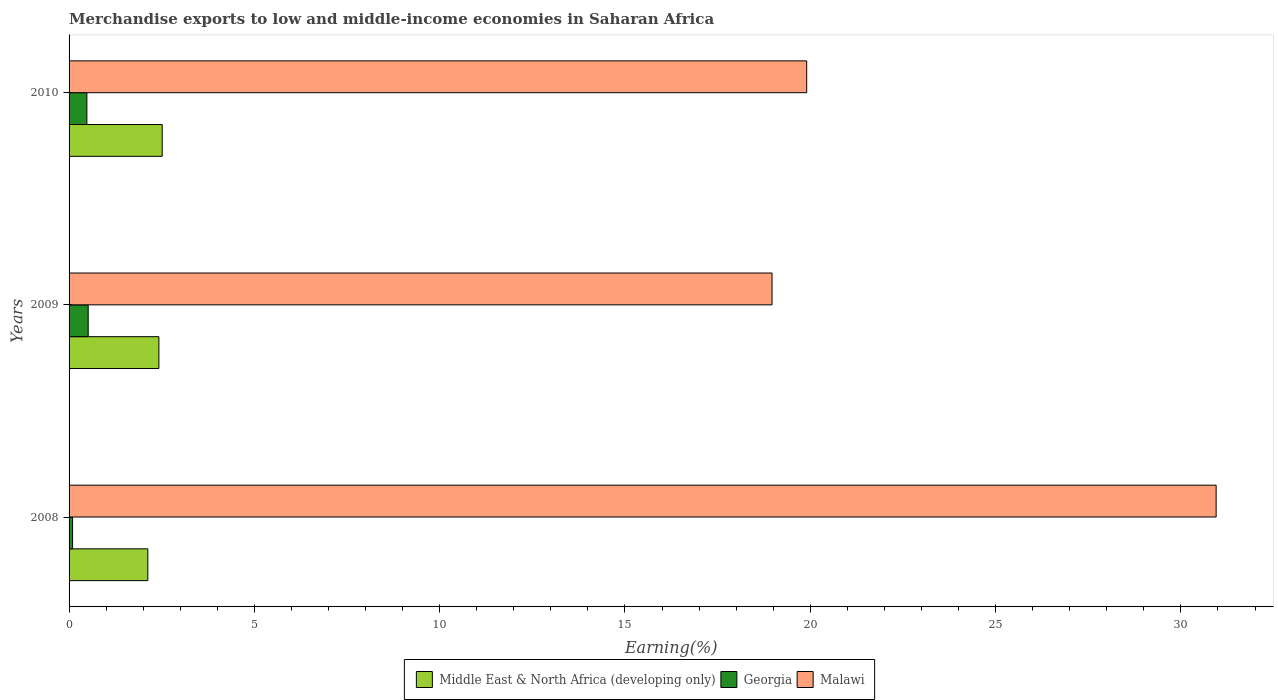How many groups of bars are there?
Offer a very short reply. 3. Are the number of bars on each tick of the Y-axis equal?
Offer a terse response. Yes. How many bars are there on the 2nd tick from the top?
Make the answer very short. 3. What is the label of the 3rd group of bars from the top?
Offer a very short reply. 2008. In how many cases, is the number of bars for a given year not equal to the number of legend labels?
Keep it short and to the point. 0. What is the percentage of amount earned from merchandise exports in Malawi in 2009?
Keep it short and to the point. 18.97. Across all years, what is the maximum percentage of amount earned from merchandise exports in Middle East & North Africa (developing only)?
Make the answer very short. 2.51. Across all years, what is the minimum percentage of amount earned from merchandise exports in Middle East & North Africa (developing only)?
Make the answer very short. 2.12. In which year was the percentage of amount earned from merchandise exports in Malawi minimum?
Your answer should be compact. 2009. What is the total percentage of amount earned from merchandise exports in Middle East & North Africa (developing only) in the graph?
Your answer should be compact. 7.06. What is the difference between the percentage of amount earned from merchandise exports in Middle East & North Africa (developing only) in 2009 and that in 2010?
Provide a succinct answer. -0.09. What is the difference between the percentage of amount earned from merchandise exports in Middle East & North Africa (developing only) in 2010 and the percentage of amount earned from merchandise exports in Georgia in 2009?
Your answer should be very brief. 2. What is the average percentage of amount earned from merchandise exports in Georgia per year?
Make the answer very short. 0.36. In the year 2008, what is the difference between the percentage of amount earned from merchandise exports in Middle East & North Africa (developing only) and percentage of amount earned from merchandise exports in Malawi?
Your answer should be compact. -28.83. What is the ratio of the percentage of amount earned from merchandise exports in Middle East & North Africa (developing only) in 2008 to that in 2009?
Your answer should be very brief. 0.88. What is the difference between the highest and the second highest percentage of amount earned from merchandise exports in Malawi?
Make the answer very short. 11.05. What is the difference between the highest and the lowest percentage of amount earned from merchandise exports in Middle East & North Africa (developing only)?
Make the answer very short. 0.39. In how many years, is the percentage of amount earned from merchandise exports in Malawi greater than the average percentage of amount earned from merchandise exports in Malawi taken over all years?
Ensure brevity in your answer.  1. What does the 2nd bar from the top in 2010 represents?
Offer a terse response. Georgia. What does the 1st bar from the bottom in 2009 represents?
Your response must be concise. Middle East & North Africa (developing only). How many bars are there?
Provide a succinct answer. 9. Are all the bars in the graph horizontal?
Make the answer very short. Yes. How many years are there in the graph?
Make the answer very short. 3. Does the graph contain any zero values?
Make the answer very short. No. Does the graph contain grids?
Offer a very short reply. No. Where does the legend appear in the graph?
Provide a succinct answer. Bottom center. What is the title of the graph?
Make the answer very short. Merchandise exports to low and middle-income economies in Saharan Africa. Does "Vietnam" appear as one of the legend labels in the graph?
Make the answer very short. No. What is the label or title of the X-axis?
Keep it short and to the point. Earning(%). What is the Earning(%) in Middle East & North Africa (developing only) in 2008?
Give a very brief answer. 2.12. What is the Earning(%) in Georgia in 2008?
Keep it short and to the point. 0.09. What is the Earning(%) of Malawi in 2008?
Offer a terse response. 30.95. What is the Earning(%) in Middle East & North Africa (developing only) in 2009?
Your answer should be compact. 2.42. What is the Earning(%) in Georgia in 2009?
Ensure brevity in your answer.  0.52. What is the Earning(%) of Malawi in 2009?
Offer a terse response. 18.97. What is the Earning(%) of Middle East & North Africa (developing only) in 2010?
Provide a succinct answer. 2.51. What is the Earning(%) of Georgia in 2010?
Your response must be concise. 0.48. What is the Earning(%) of Malawi in 2010?
Offer a very short reply. 19.9. Across all years, what is the maximum Earning(%) of Middle East & North Africa (developing only)?
Offer a very short reply. 2.51. Across all years, what is the maximum Earning(%) of Georgia?
Offer a terse response. 0.52. Across all years, what is the maximum Earning(%) of Malawi?
Offer a terse response. 30.95. Across all years, what is the minimum Earning(%) in Middle East & North Africa (developing only)?
Provide a succinct answer. 2.12. Across all years, what is the minimum Earning(%) of Georgia?
Ensure brevity in your answer.  0.09. Across all years, what is the minimum Earning(%) of Malawi?
Make the answer very short. 18.97. What is the total Earning(%) of Middle East & North Africa (developing only) in the graph?
Your answer should be very brief. 7.06. What is the total Earning(%) in Georgia in the graph?
Your response must be concise. 1.09. What is the total Earning(%) in Malawi in the graph?
Your answer should be compact. 69.82. What is the difference between the Earning(%) of Middle East & North Africa (developing only) in 2008 and that in 2009?
Make the answer very short. -0.3. What is the difference between the Earning(%) of Georgia in 2008 and that in 2009?
Keep it short and to the point. -0.42. What is the difference between the Earning(%) in Malawi in 2008 and that in 2009?
Keep it short and to the point. 11.98. What is the difference between the Earning(%) of Middle East & North Africa (developing only) in 2008 and that in 2010?
Your response must be concise. -0.39. What is the difference between the Earning(%) in Georgia in 2008 and that in 2010?
Ensure brevity in your answer.  -0.39. What is the difference between the Earning(%) in Malawi in 2008 and that in 2010?
Make the answer very short. 11.05. What is the difference between the Earning(%) of Middle East & North Africa (developing only) in 2009 and that in 2010?
Ensure brevity in your answer.  -0.09. What is the difference between the Earning(%) in Georgia in 2009 and that in 2010?
Make the answer very short. 0.04. What is the difference between the Earning(%) of Malawi in 2009 and that in 2010?
Your answer should be very brief. -0.93. What is the difference between the Earning(%) of Middle East & North Africa (developing only) in 2008 and the Earning(%) of Georgia in 2009?
Make the answer very short. 1.61. What is the difference between the Earning(%) of Middle East & North Africa (developing only) in 2008 and the Earning(%) of Malawi in 2009?
Make the answer very short. -16.84. What is the difference between the Earning(%) in Georgia in 2008 and the Earning(%) in Malawi in 2009?
Keep it short and to the point. -18.87. What is the difference between the Earning(%) of Middle East & North Africa (developing only) in 2008 and the Earning(%) of Georgia in 2010?
Your response must be concise. 1.64. What is the difference between the Earning(%) of Middle East & North Africa (developing only) in 2008 and the Earning(%) of Malawi in 2010?
Offer a very short reply. -17.78. What is the difference between the Earning(%) in Georgia in 2008 and the Earning(%) in Malawi in 2010?
Ensure brevity in your answer.  -19.81. What is the difference between the Earning(%) in Middle East & North Africa (developing only) in 2009 and the Earning(%) in Georgia in 2010?
Your response must be concise. 1.94. What is the difference between the Earning(%) of Middle East & North Africa (developing only) in 2009 and the Earning(%) of Malawi in 2010?
Ensure brevity in your answer.  -17.48. What is the difference between the Earning(%) in Georgia in 2009 and the Earning(%) in Malawi in 2010?
Your answer should be compact. -19.39. What is the average Earning(%) in Middle East & North Africa (developing only) per year?
Your answer should be compact. 2.35. What is the average Earning(%) of Georgia per year?
Provide a succinct answer. 0.36. What is the average Earning(%) of Malawi per year?
Your answer should be very brief. 23.27. In the year 2008, what is the difference between the Earning(%) in Middle East & North Africa (developing only) and Earning(%) in Georgia?
Your answer should be compact. 2.03. In the year 2008, what is the difference between the Earning(%) of Middle East & North Africa (developing only) and Earning(%) of Malawi?
Your answer should be compact. -28.83. In the year 2008, what is the difference between the Earning(%) in Georgia and Earning(%) in Malawi?
Offer a terse response. -30.86. In the year 2009, what is the difference between the Earning(%) in Middle East & North Africa (developing only) and Earning(%) in Georgia?
Give a very brief answer. 1.91. In the year 2009, what is the difference between the Earning(%) of Middle East & North Africa (developing only) and Earning(%) of Malawi?
Offer a very short reply. -16.54. In the year 2009, what is the difference between the Earning(%) in Georgia and Earning(%) in Malawi?
Your response must be concise. -18.45. In the year 2010, what is the difference between the Earning(%) in Middle East & North Africa (developing only) and Earning(%) in Georgia?
Your answer should be very brief. 2.03. In the year 2010, what is the difference between the Earning(%) of Middle East & North Africa (developing only) and Earning(%) of Malawi?
Your response must be concise. -17.39. In the year 2010, what is the difference between the Earning(%) in Georgia and Earning(%) in Malawi?
Make the answer very short. -19.42. What is the ratio of the Earning(%) of Middle East & North Africa (developing only) in 2008 to that in 2009?
Your answer should be very brief. 0.88. What is the ratio of the Earning(%) of Georgia in 2008 to that in 2009?
Provide a succinct answer. 0.18. What is the ratio of the Earning(%) of Malawi in 2008 to that in 2009?
Give a very brief answer. 1.63. What is the ratio of the Earning(%) in Middle East & North Africa (developing only) in 2008 to that in 2010?
Your answer should be very brief. 0.85. What is the ratio of the Earning(%) in Georgia in 2008 to that in 2010?
Make the answer very short. 0.2. What is the ratio of the Earning(%) of Malawi in 2008 to that in 2010?
Make the answer very short. 1.56. What is the ratio of the Earning(%) in Middle East & North Africa (developing only) in 2009 to that in 2010?
Make the answer very short. 0.96. What is the ratio of the Earning(%) of Georgia in 2009 to that in 2010?
Keep it short and to the point. 1.07. What is the ratio of the Earning(%) of Malawi in 2009 to that in 2010?
Make the answer very short. 0.95. What is the difference between the highest and the second highest Earning(%) in Middle East & North Africa (developing only)?
Provide a succinct answer. 0.09. What is the difference between the highest and the second highest Earning(%) in Georgia?
Your answer should be very brief. 0.04. What is the difference between the highest and the second highest Earning(%) of Malawi?
Give a very brief answer. 11.05. What is the difference between the highest and the lowest Earning(%) of Middle East & North Africa (developing only)?
Keep it short and to the point. 0.39. What is the difference between the highest and the lowest Earning(%) in Georgia?
Offer a terse response. 0.42. What is the difference between the highest and the lowest Earning(%) of Malawi?
Offer a very short reply. 11.98. 